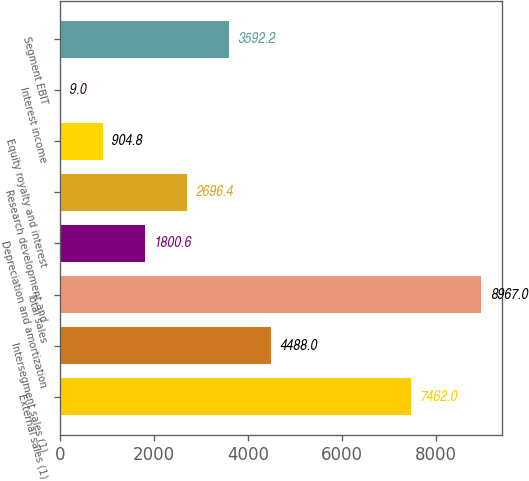<chart> <loc_0><loc_0><loc_500><loc_500><bar_chart><fcel>External sales (1)<fcel>Intersegment sales (1)<fcel>Total sales<fcel>Depreciation and amortization<fcel>Research development and<fcel>Equity royalty and interest<fcel>Interest income<fcel>Segment EBIT<nl><fcel>7462<fcel>4488<fcel>8967<fcel>1800.6<fcel>2696.4<fcel>904.8<fcel>9<fcel>3592.2<nl></chart> 